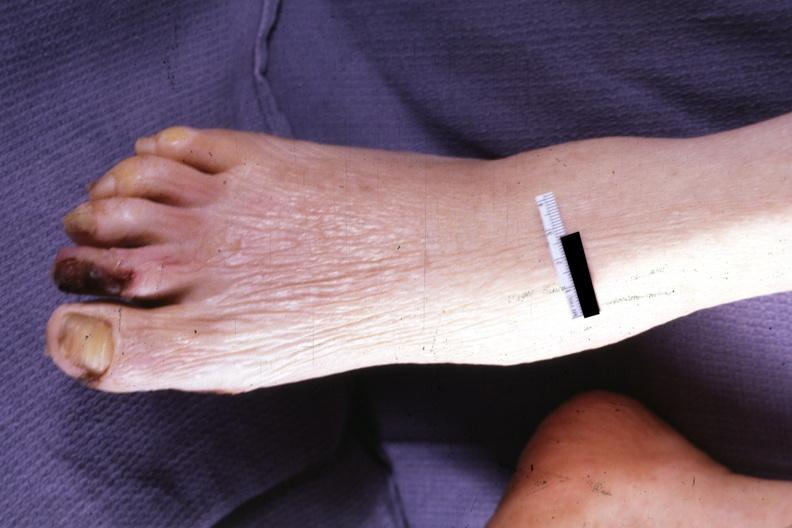re extremities present?
Answer the question using a single word or phrase. Yes 